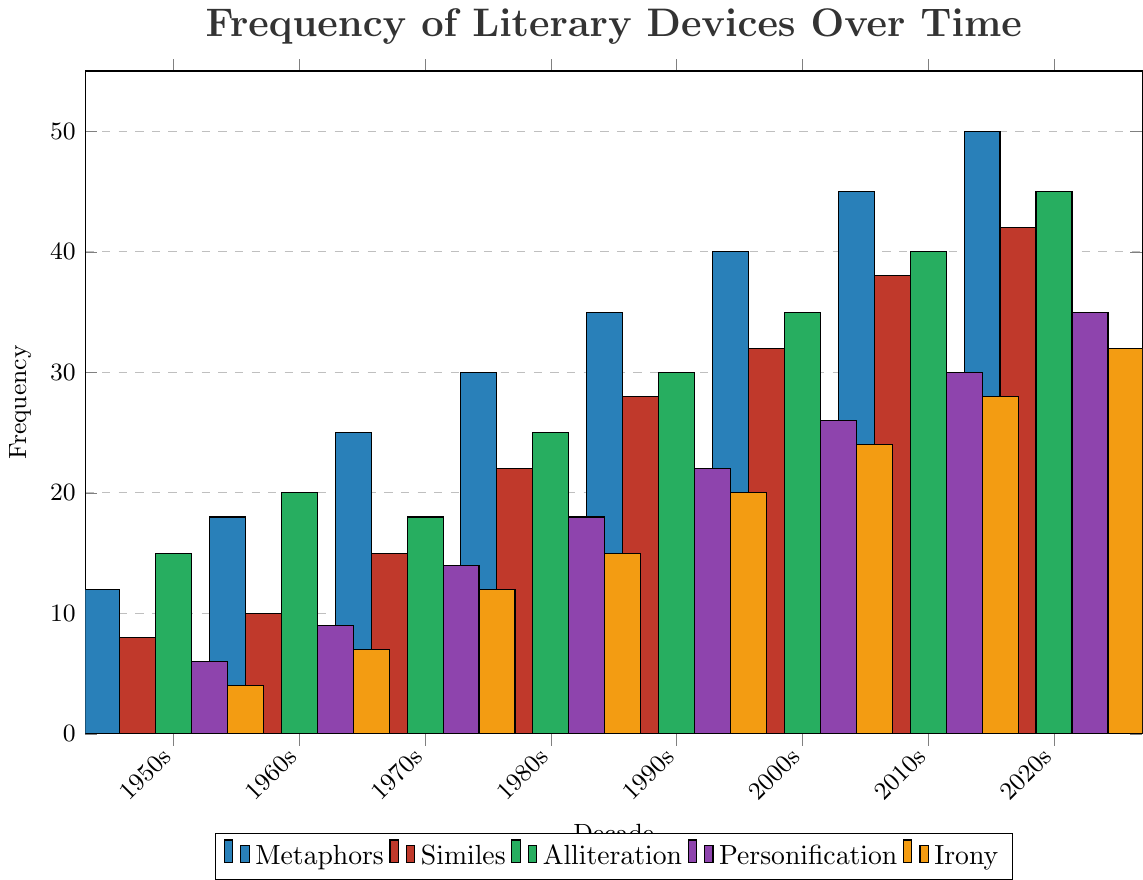Which decade has the highest frequency of metaphors? Look at the blue bars in the chart and identify the tallest one. The tallest blue bar corresponds to the 2020s with a value of 50.
Answer: 2020s How many more similes were used in the 2010s compared to the 1950s? Find the height of the red bars for both decades and subtract the smaller value from the larger one. For the 2010s, there are 38 similes, and for the 1950s, there are 8 similes. So, the difference is 38 - 8 = 30.
Answer: 30 Which literary device saw the largest increase in usage from the 1950s to the 2020s? Calculate the difference in frequency between the 1950s and the 2020s for each device and compare. Metaphors increased from 12 to 50 (difference of 38), similes increased from 8 to 42 (difference of 34), alliteration increased from 15 to 45 (difference of 30), personification increased from 6 to 35 (difference of 29), irony increased from 4 to 32 (difference of 28). The largest increase is for metaphors.
Answer: Metaphors What is the total frequency of all literary devices in the 1990s? Sum the frequencies of each literary device in the 1990s. The frequencies are: Metaphors = 35, Similes = 28, Alliteration = 30, Personification = 22, Irony = 20. The total is 35 + 28 + 30 + 22 + 20 = 135.
Answer: 135 Did similes ever have a higher frequency than metaphors in any decade? Compare the heights of the red and blue bars across all decades. Similes (red bars) are always shorter than metaphors (blue bars) in every decade.
Answer: No How much did the frequency of personification change from the 1980s to the 2000s? Identify the heights of the purple bars in both decades and find the difference. In the 1980s, personification is 18, and in the 2000s, it is 26. The change is 26 - 18 = 8.
Answer: 8 Which decade shows the smallest frequency of irony? Look for the shortest yellow bar in the chart and note the corresponding decade. The shortest bar for irony is in the 1950s with a value of 4.
Answer: 1950s On average, how many metaphors were used in each decade? To find the average, add up the number of metaphors for all decades and divide by the number of decades. The values are: 12, 18, 25, 30, 35, 40, 45, 50. Sum = 12 + 18 + 25 + 30 + 35 + 40 + 45 + 50 = 255. There are 8 decades, so the average is 255 / 8 = 31.875.
Answer: 31.875 Which decade saw the largest use of alliteration? Identify the tallest green bar in the chart and its corresponding decade. The tallest green bar is in the 2020s with a frequency of 45.
Answer: 2020s 